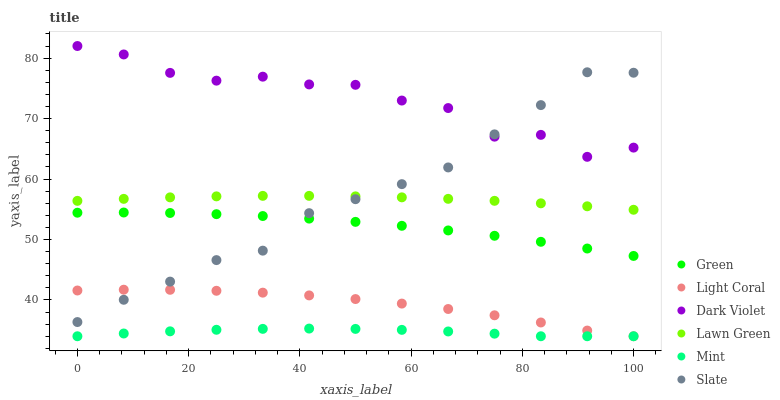Does Mint have the minimum area under the curve?
Answer yes or no. Yes. Does Dark Violet have the maximum area under the curve?
Answer yes or no. Yes. Does Slate have the minimum area under the curve?
Answer yes or no. No. Does Slate have the maximum area under the curve?
Answer yes or no. No. Is Lawn Green the smoothest?
Answer yes or no. Yes. Is Dark Violet the roughest?
Answer yes or no. Yes. Is Slate the smoothest?
Answer yes or no. No. Is Slate the roughest?
Answer yes or no. No. Does Light Coral have the lowest value?
Answer yes or no. Yes. Does Slate have the lowest value?
Answer yes or no. No. Does Dark Violet have the highest value?
Answer yes or no. Yes. Does Slate have the highest value?
Answer yes or no. No. Is Mint less than Slate?
Answer yes or no. Yes. Is Dark Violet greater than Green?
Answer yes or no. Yes. Does Mint intersect Light Coral?
Answer yes or no. Yes. Is Mint less than Light Coral?
Answer yes or no. No. Is Mint greater than Light Coral?
Answer yes or no. No. Does Mint intersect Slate?
Answer yes or no. No. 